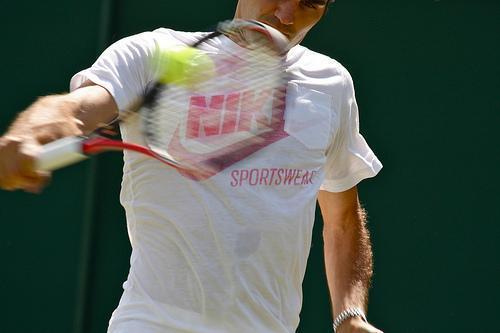How many people are in this picture?
Give a very brief answer. 1. 